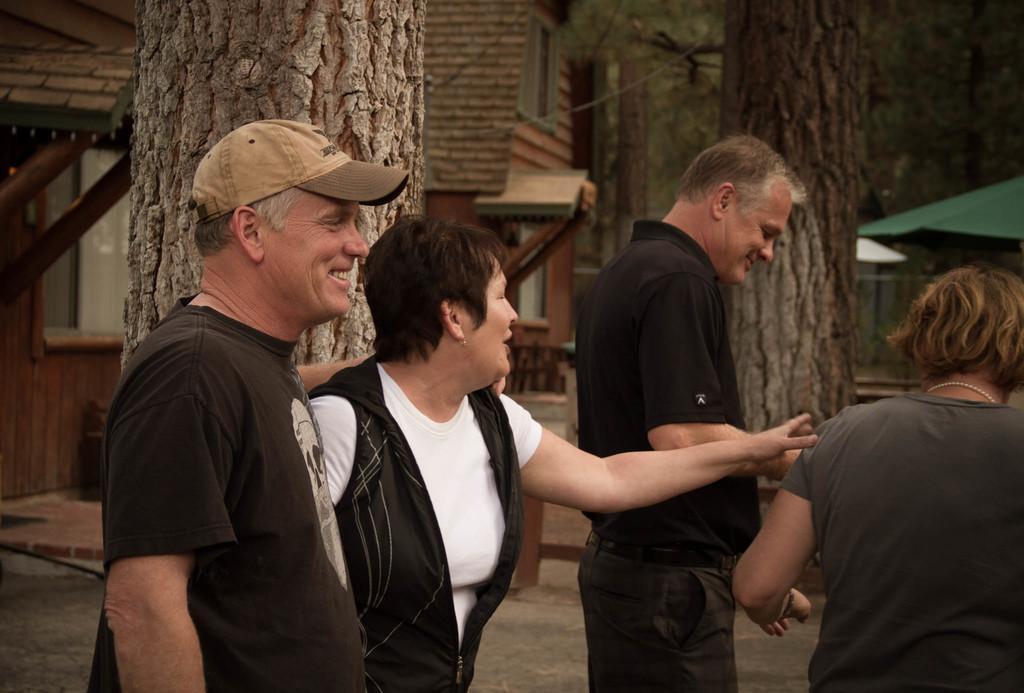Could you give a brief overview of what you see in this image? In this picture I can observe four members. Two of them are men and the remaining two are women. In the background I can observe trees and houses. 